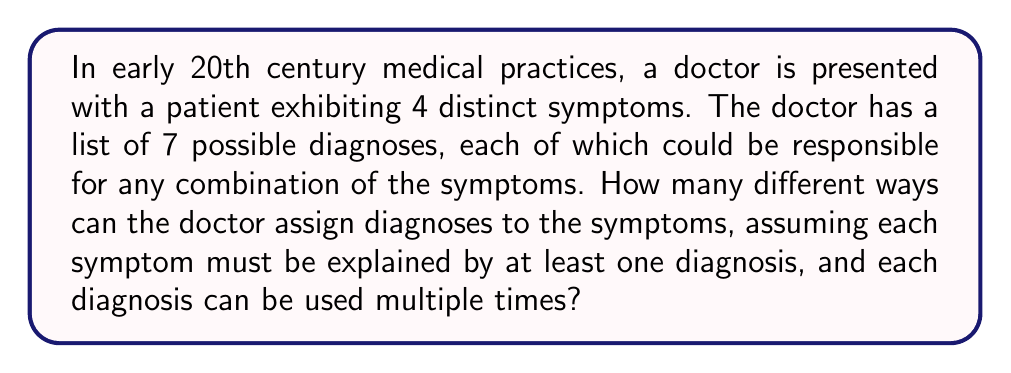Could you help me with this problem? Let's approach this step-by-step:

1) First, we need to understand that this is a problem of distributing the 4 symptoms among the 7 diagnoses, where each symptom must be assigned to at least one diagnosis, and each diagnosis can be used multiple times.

2) This scenario can be modeled using the concept of set partitions with repetition allowed. In this case, we're partitioning the set of symptoms into non-empty subsets, where each subset corresponds to a diagnosis.

3) The formula for the number of ways to partition a set of $n$ elements into $k$ or fewer non-empty subsets with repetition allowed is:

   $${k^n - \sum_{i=1}^{k-1} \binom{k}{i}(k-i)^n}$$

4) In our case, $n = 4$ (symptoms) and $k = 7$ (diagnoses).

5) Let's substitute these values into the formula:

   $$7^4 - \sum_{i=1}^{6} \binom{7}{i}(7-i)^4$$

6) Expand this:
   $$7^4 - [\binom{7}{1}6^4 + \binom{7}{2}5^4 + \binom{7}{3}4^4 + \binom{7}{4}3^4 + \binom{7}{5}2^4 + \binom{7}{6}1^4]$$

7) Calculate each term:
   $$2401 - [7 \cdot 1296 + 21 \cdot 625 + 35 \cdot 256 + 35 \cdot 81 + 21 \cdot 16 + 7 \cdot 1]$$

8) Simplify:
   $$2401 - [9072 + 13125 + 8960 + 2835 + 336 + 7]$$

9) Final calculation:
   $$2401 - 34335 = -31934$$

10) However, since we can't have a negative number of ways, we take the absolute value.
Answer: 31934 